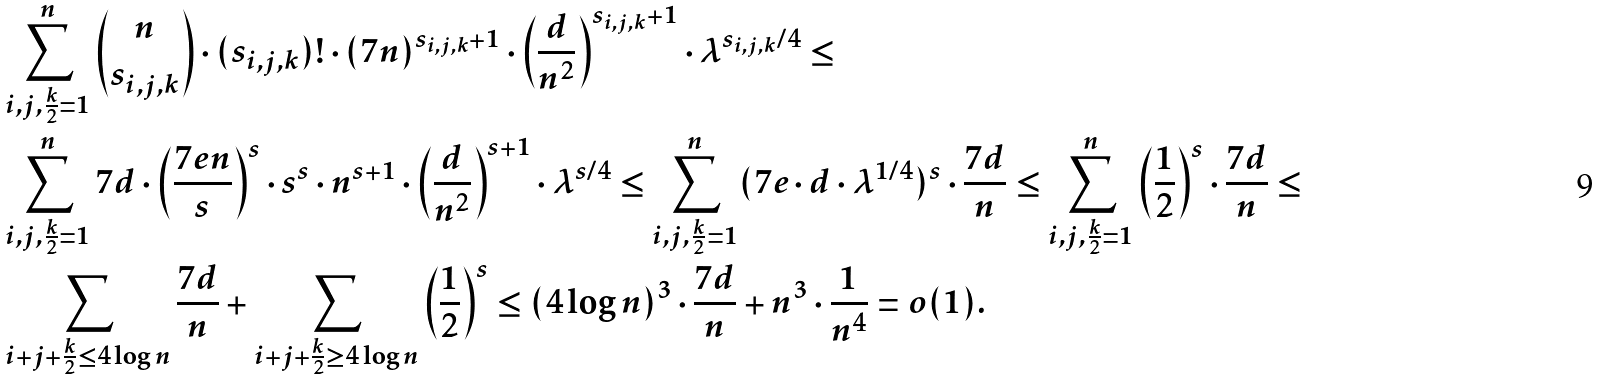<formula> <loc_0><loc_0><loc_500><loc_500>& \sum _ { i , j , \frac { k } { 2 } = 1 } ^ { n } \binom { n } { s _ { i , j , k } } \cdot ( s _ { i , j , k } ) ! \cdot ( 7 n ) ^ { s _ { i , j , k } + 1 } \cdot \left ( \frac { d } { n ^ { 2 } } \right ) ^ { s _ { i , j , k } + 1 } \cdot \lambda ^ { s _ { i , j , k } / 4 } \leq \\ & \sum _ { i , j , \frac { k } { 2 } = 1 } ^ { n } 7 d \cdot \left ( \frac { 7 e n } { s } \right ) ^ { s } \cdot s ^ { s } \cdot n ^ { s + 1 } \cdot \left ( \frac { d } { n ^ { 2 } } \right ) ^ { s + 1 } \cdot \lambda ^ { s / 4 } \leq \sum _ { i , j , \frac { k } { 2 } = 1 } ^ { n } ( 7 e \cdot d \cdot \lambda ^ { 1 / 4 } ) ^ { s } \cdot \frac { 7 d } { n } \leq \sum _ { i , j , \frac { k } { 2 } = 1 } ^ { n } \left ( \frac { 1 } { 2 } \right ) ^ { s } \cdot \frac { 7 d } { n } \leq \\ & \sum _ { i + j + \frac { k } { 2 } \leq 4 \log n } \frac { 7 d } { n } + \sum _ { i + j + \frac { k } { 2 } \geq 4 \log n } \left ( \frac { 1 } { 2 } \right ) ^ { s } \leq ( 4 \log n ) ^ { 3 } \cdot \frac { 7 d } { n } + n ^ { 3 } \cdot \frac { 1 } { n ^ { 4 } } = o ( 1 ) .</formula> 